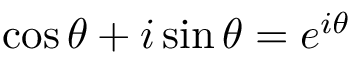Convert formula to latex. <formula><loc_0><loc_0><loc_500><loc_500>\cos \theta + i \sin \theta = e ^ { i \theta }</formula> 